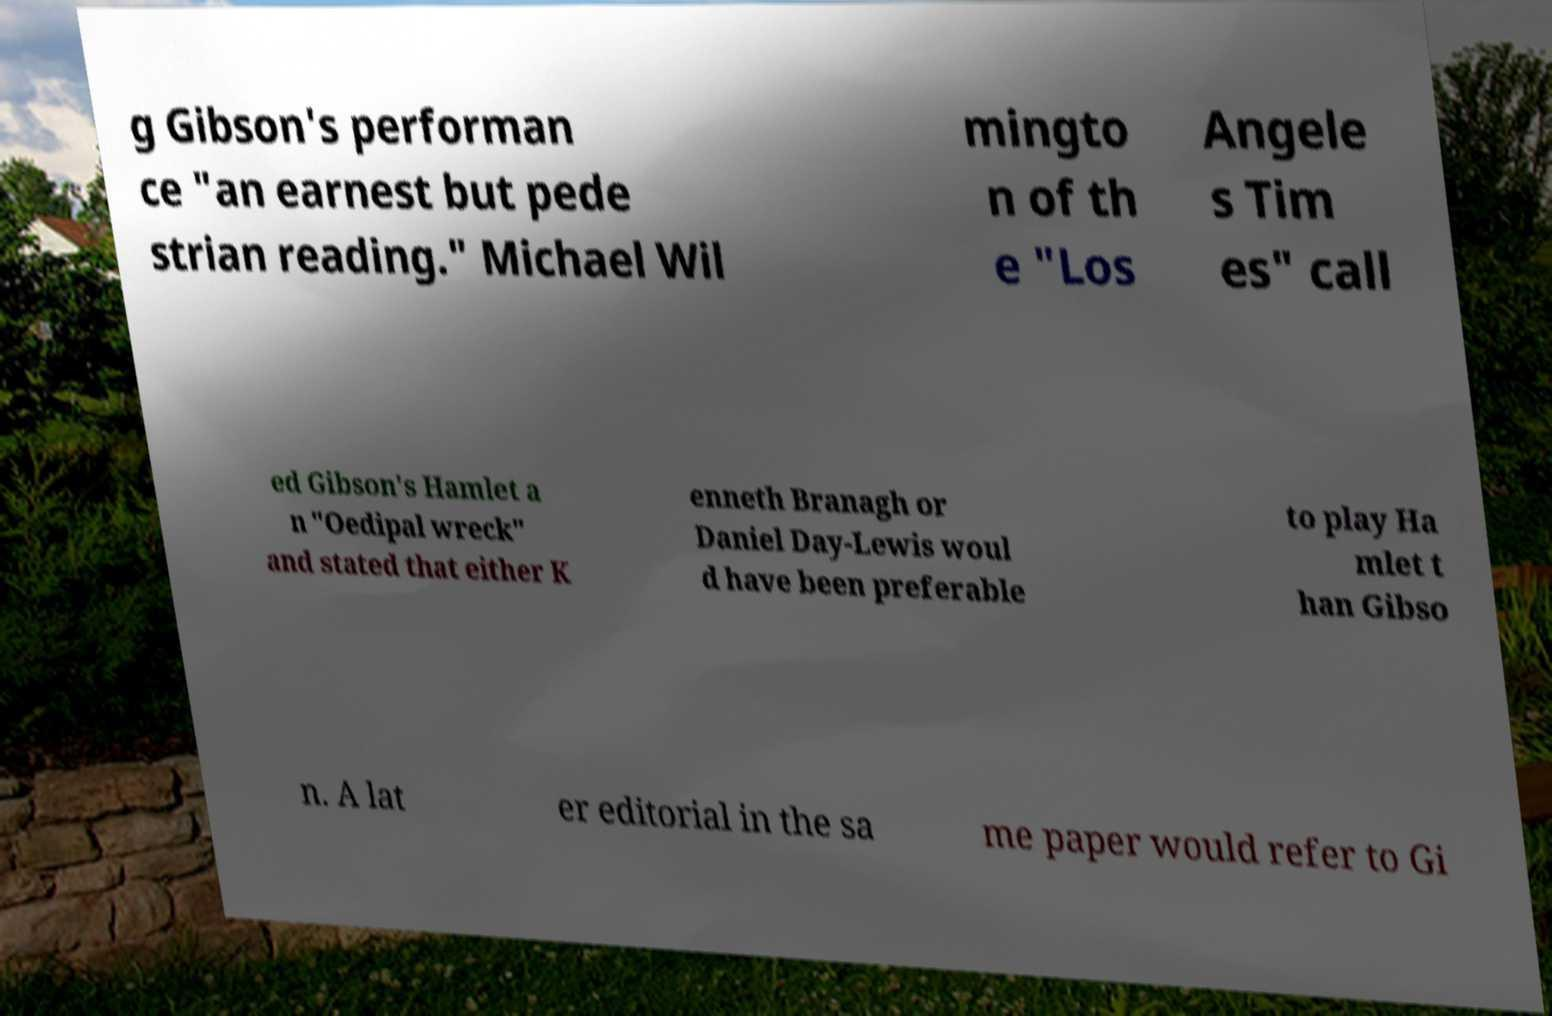Please identify and transcribe the text found in this image. g Gibson's performan ce "an earnest but pede strian reading." Michael Wil mingto n of th e "Los Angele s Tim es" call ed Gibson's Hamlet a n "Oedipal wreck" and stated that either K enneth Branagh or Daniel Day-Lewis woul d have been preferable to play Ha mlet t han Gibso n. A lat er editorial in the sa me paper would refer to Gi 